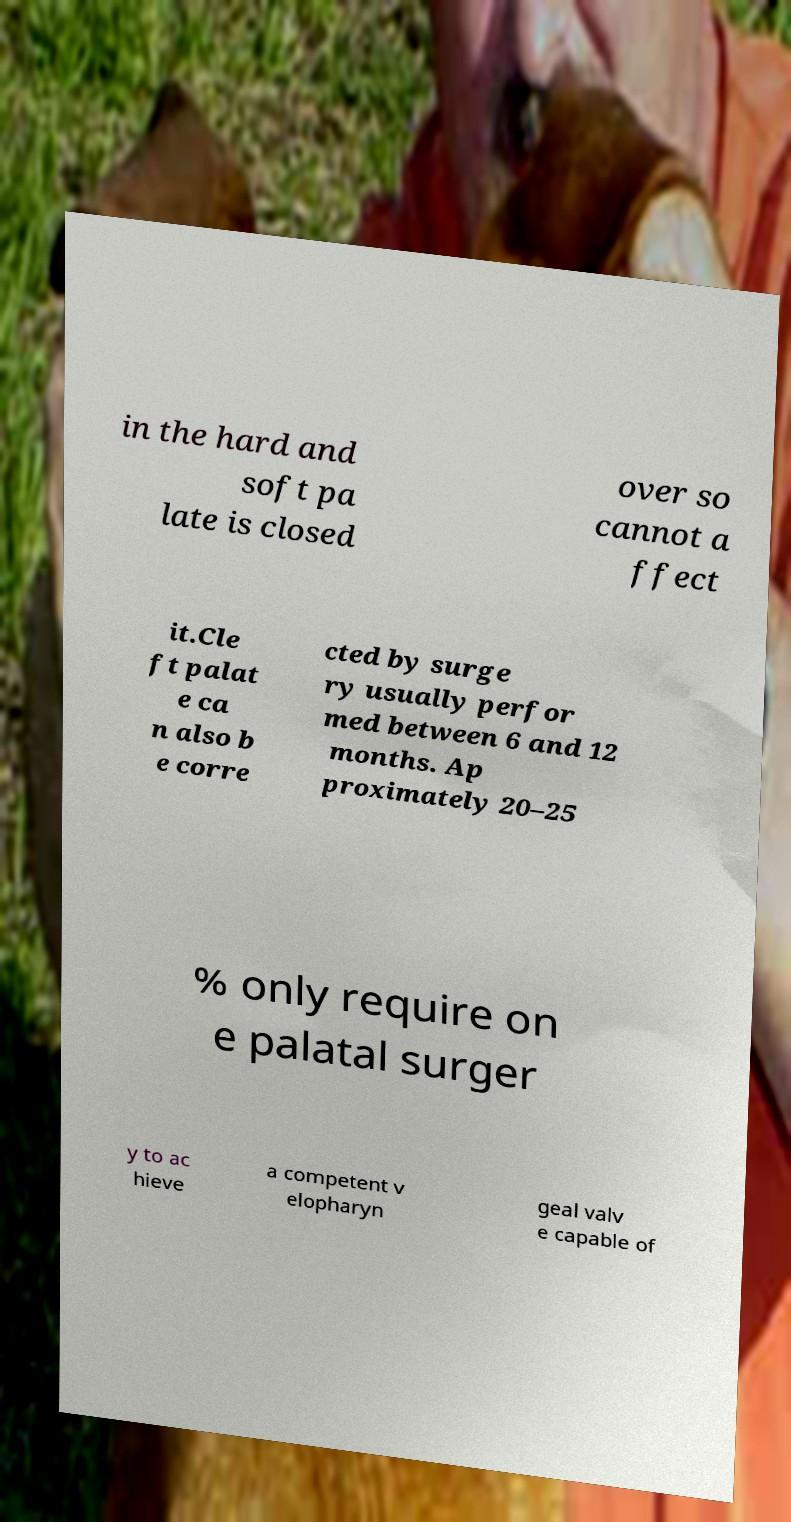For documentation purposes, I need the text within this image transcribed. Could you provide that? in the hard and soft pa late is closed over so cannot a ffect it.Cle ft palat e ca n also b e corre cted by surge ry usually perfor med between 6 and 12 months. Ap proximately 20–25 % only require on e palatal surger y to ac hieve a competent v elopharyn geal valv e capable of 